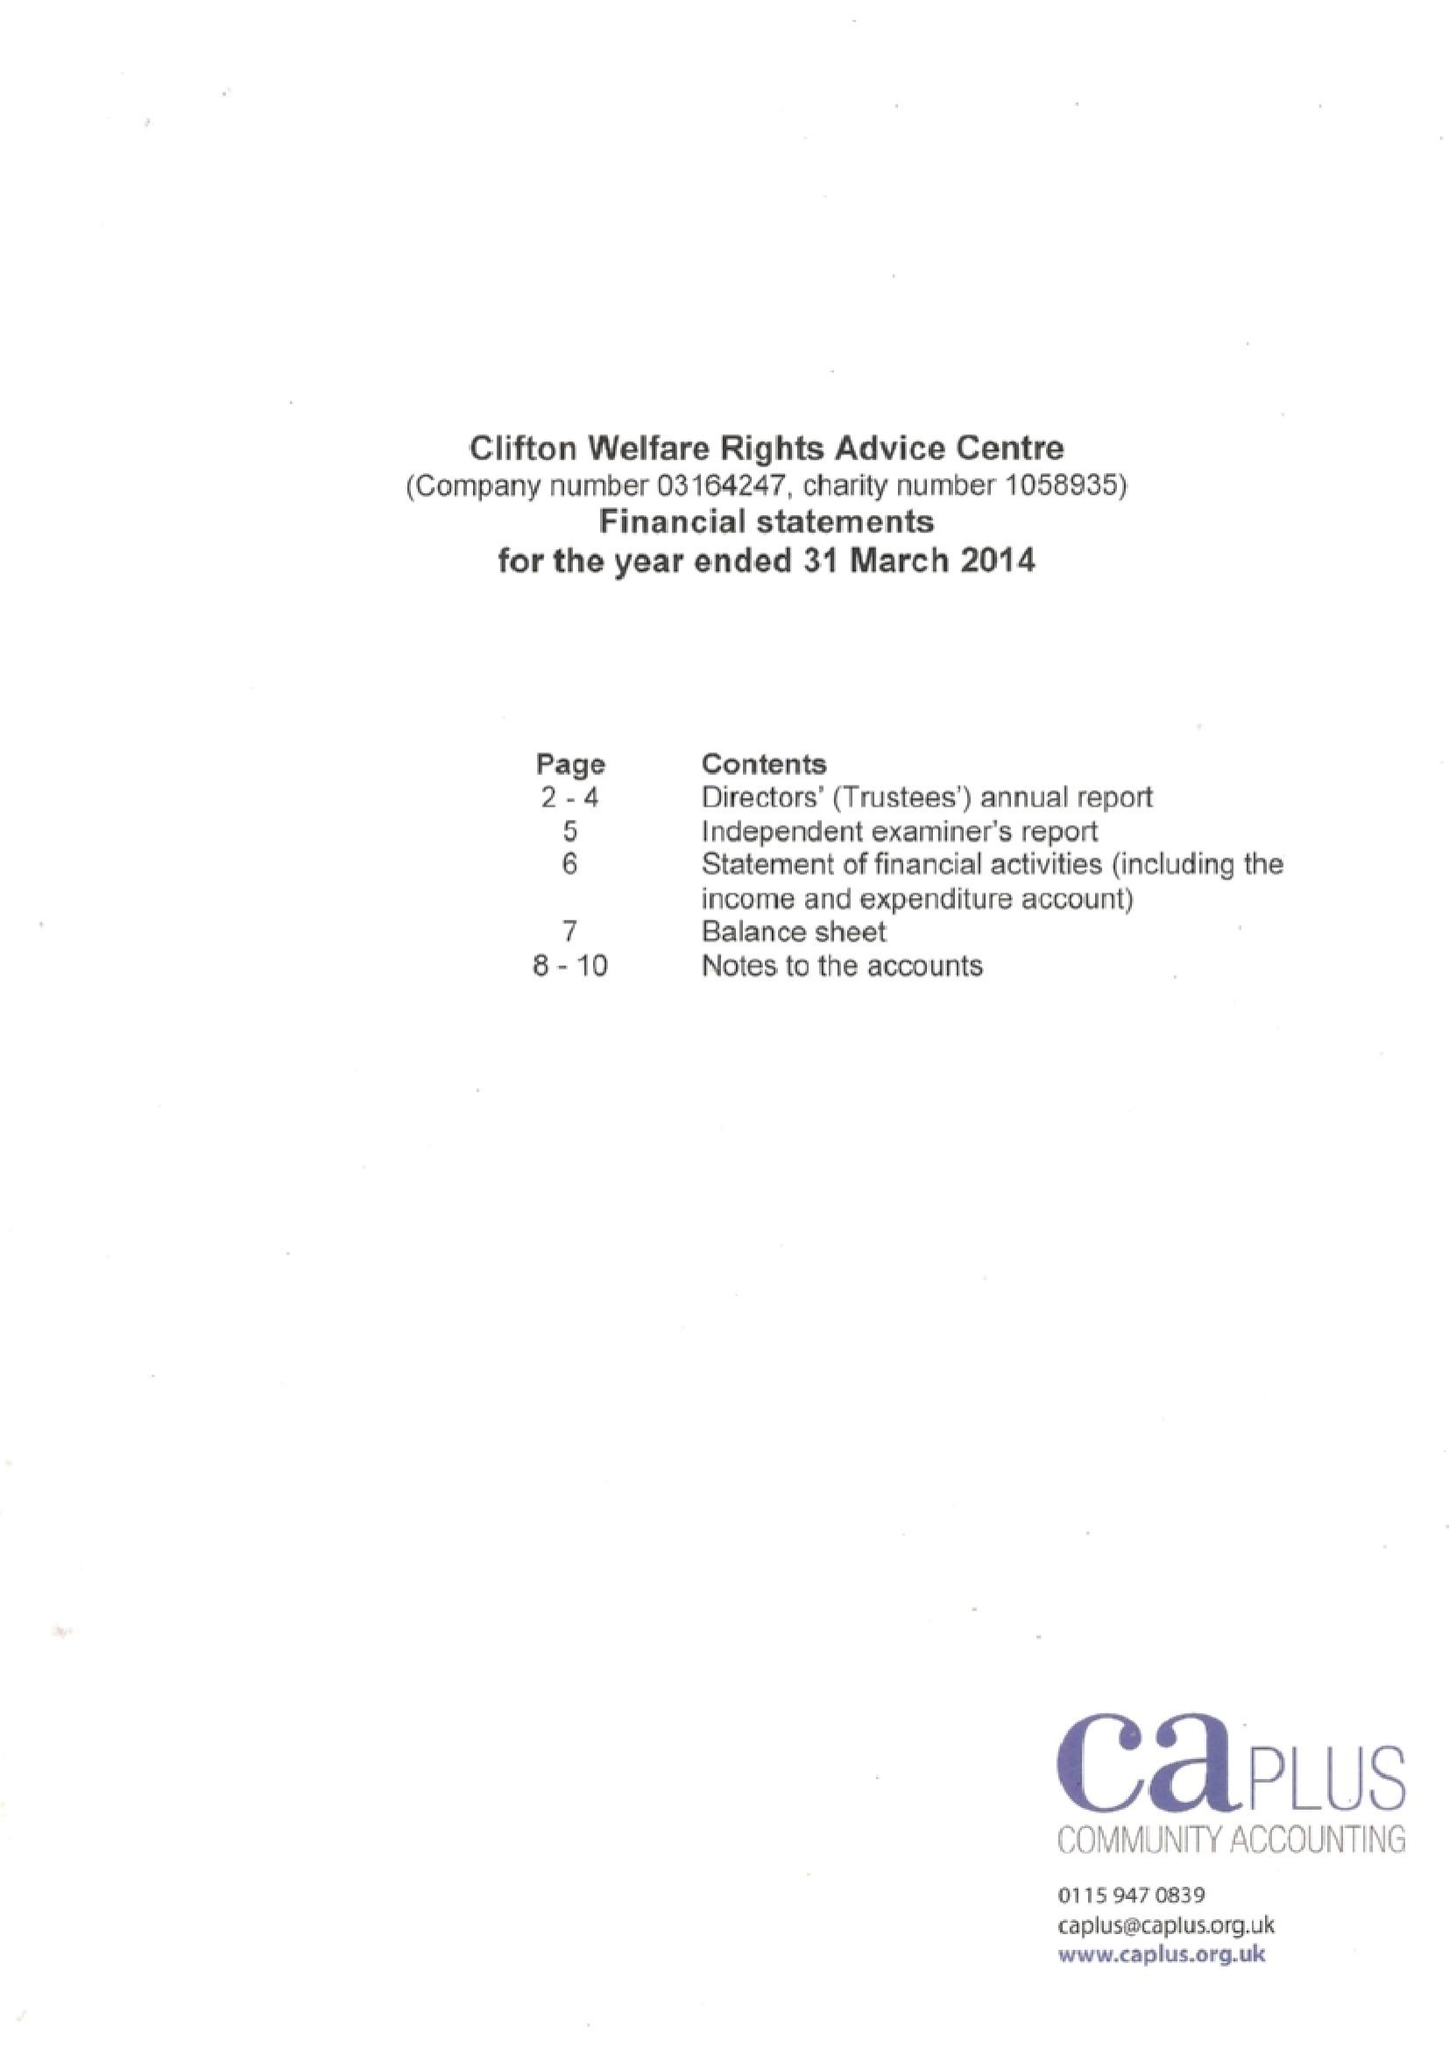What is the value for the address__postcode?
Answer the question using a single word or phrase. NG11 8EW 